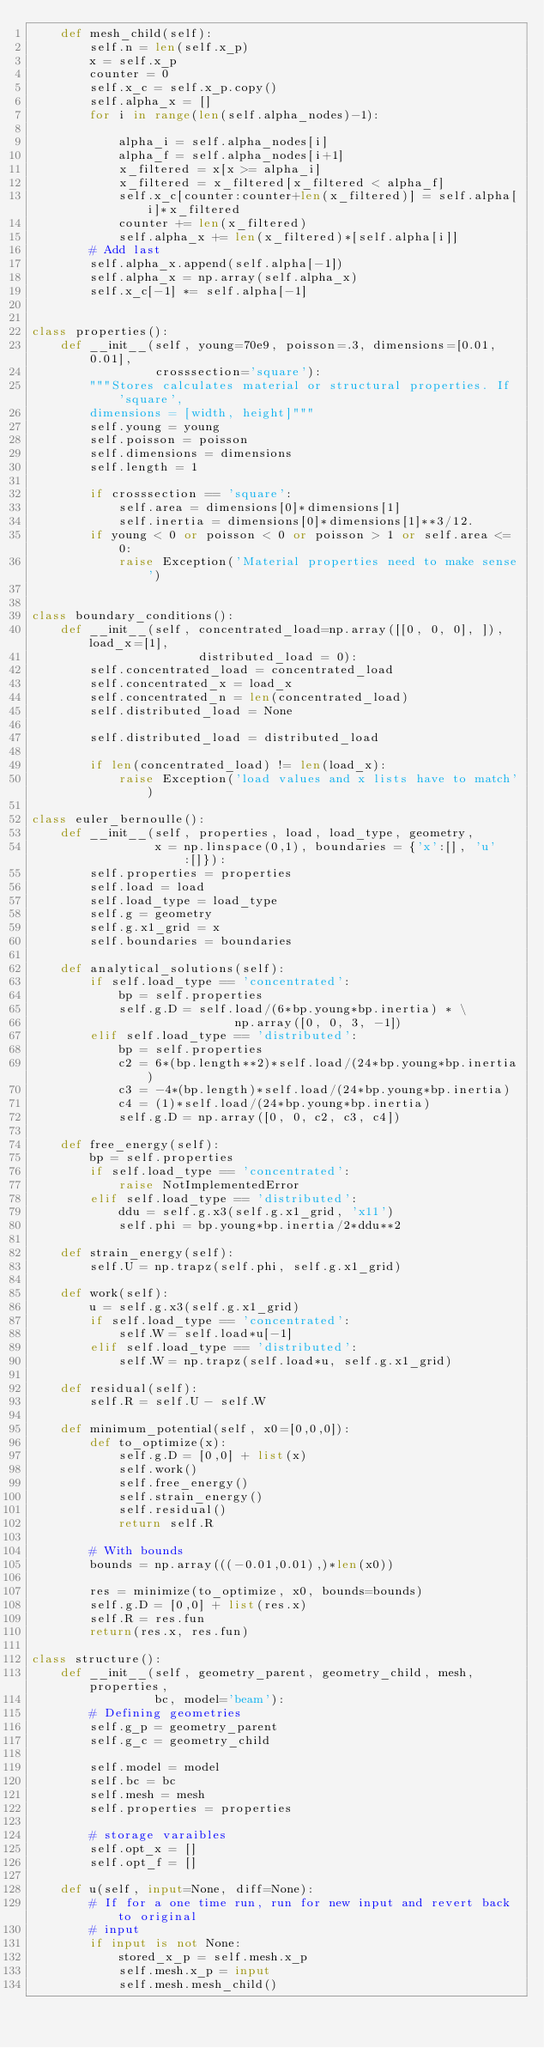<code> <loc_0><loc_0><loc_500><loc_500><_Python_>    def mesh_child(self):
        self.n = len(self.x_p)
        x = self.x_p
        counter = 0
        self.x_c = self.x_p.copy()
        self.alpha_x = []
        for i in range(len(self.alpha_nodes)-1):

            alpha_i = self.alpha_nodes[i]
            alpha_f = self.alpha_nodes[i+1]
            x_filtered = x[x >= alpha_i]
            x_filtered = x_filtered[x_filtered < alpha_f]
            self.x_c[counter:counter+len(x_filtered)] = self.alpha[i]*x_filtered
            counter += len(x_filtered)
            self.alpha_x += len(x_filtered)*[self.alpha[i]]
        # Add last
        self.alpha_x.append(self.alpha[-1])
        self.alpha_x = np.array(self.alpha_x)
        self.x_c[-1] *= self.alpha[-1]


class properties():
    def __init__(self, young=70e9, poisson=.3, dimensions=[0.01, 0.01],
                 crosssection='square'):
        """Stores calculates material or structural properties. If 'square',
        dimensions = [width, height]"""
        self.young = young
        self.poisson = poisson
        self.dimensions = dimensions
        self.length = 1

        if crosssection == 'square':
            self.area = dimensions[0]*dimensions[1]
            self.inertia = dimensions[0]*dimensions[1]**3/12.
        if young < 0 or poisson < 0 or poisson > 1 or self.area <= 0:
            raise Exception('Material properties need to make sense')


class boundary_conditions():
    def __init__(self, concentrated_load=np.array([[0, 0, 0], ]), load_x=[1],
                       distributed_load = 0):
        self.concentrated_load = concentrated_load
        self.concentrated_x = load_x
        self.concentrated_n = len(concentrated_load)
        self.distributed_load = None

        self.distributed_load = distributed_load

        if len(concentrated_load) != len(load_x):
            raise Exception('load values and x lists have to match')

class euler_bernoulle():
    def __init__(self, properties, load, load_type, geometry,
                 x = np.linspace(0,1), boundaries = {'x':[], 'u':[]}):
        self.properties = properties
        self.load = load
        self.load_type = load_type
        self.g = geometry
        self.g.x1_grid = x
        self.boundaries = boundaries

    def analytical_solutions(self):
        if self.load_type == 'concentrated':
            bp = self.properties
            self.g.D = self.load/(6*bp.young*bp.inertia) * \
                            np.array([0, 0, 3, -1])
        elif self.load_type == 'distributed':
            bp = self.properties
            c2 = 6*(bp.length**2)*self.load/(24*bp.young*bp.inertia)
            c3 = -4*(bp.length)*self.load/(24*bp.young*bp.inertia)
            c4 = (1)*self.load/(24*bp.young*bp.inertia)
            self.g.D = np.array([0, 0, c2, c3, c4])

    def free_energy(self):
        bp = self.properties
        if self.load_type == 'concentrated':
            raise NotImplementedError
        elif self.load_type == 'distributed':
            ddu = self.g.x3(self.g.x1_grid, 'x11')
            self.phi = bp.young*bp.inertia/2*ddu**2

    def strain_energy(self):
        self.U = np.trapz(self.phi, self.g.x1_grid)

    def work(self):
        u = self.g.x3(self.g.x1_grid)
        if self.load_type == 'concentrated':
            self.W = self.load*u[-1]
        elif self.load_type == 'distributed':
            self.W = np.trapz(self.load*u, self.g.x1_grid)

    def residual(self):
        self.R = self.U - self.W

    def minimum_potential(self, x0=[0,0,0]):
        def to_optimize(x):
            self.g.D = [0,0] + list(x)
            self.work()
            self.free_energy()
            self.strain_energy()
            self.residual()
            return self.R

        # With bounds
        bounds = np.array(((-0.01,0.01),)*len(x0))

        res = minimize(to_optimize, x0, bounds=bounds)
        self.g.D = [0,0] + list(res.x)
        self.R = res.fun
        return(res.x, res.fun)

class structure():
    def __init__(self, geometry_parent, geometry_child, mesh, properties,
                 bc, model='beam'):
        # Defining geometries
        self.g_p = geometry_parent
        self.g_c = geometry_child

        self.model = model
        self.bc = bc
        self.mesh = mesh
        self.properties = properties

        # storage varaibles
        self.opt_x = []
        self.opt_f = []

    def u(self, input=None, diff=None):
        # If for a one time run, run for new input and revert back to original
        # input
        if input is not None:
            stored_x_p = self.mesh.x_p
            self.mesh.x_p = input
            self.mesh.mesh_child()
</code> 